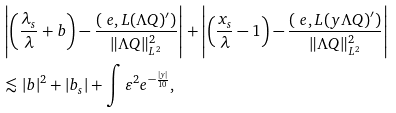<formula> <loc_0><loc_0><loc_500><loc_500>& \left | \left ( { \frac { { \lambda } _ { s } } { \lambda } } + { b } \right ) - \frac { ( \ e , L ( \Lambda Q ) ^ { \prime } ) } { \| \Lambda Q \| _ { L ^ { 2 } } ^ { 2 } } \right | + \left | \left ( { \frac { x _ { s } } { \lambda } } - 1 \right ) - \frac { ( \ e , L ( y \Lambda Q ) ^ { \prime } ) } { \| \Lambda Q \| _ { L ^ { 2 } } ^ { 2 } } \right | \\ & \lesssim | b | ^ { 2 } + | { b } _ { s } | + \int \varepsilon ^ { 2 } e ^ { - \frac { | y | } { 1 0 } } ,</formula> 